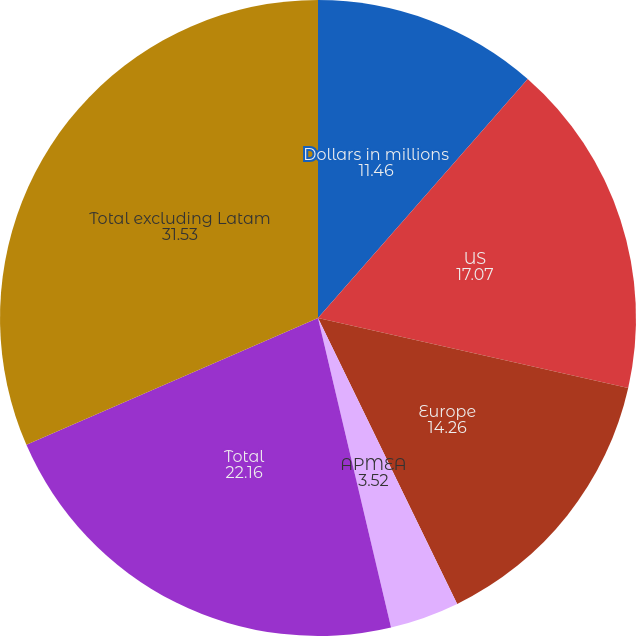Convert chart to OTSL. <chart><loc_0><loc_0><loc_500><loc_500><pie_chart><fcel>Dollars in millions<fcel>US<fcel>Europe<fcel>APMEA<fcel>Total<fcel>Total excluding Latam<nl><fcel>11.46%<fcel>17.07%<fcel>14.26%<fcel>3.52%<fcel>22.16%<fcel>31.53%<nl></chart> 